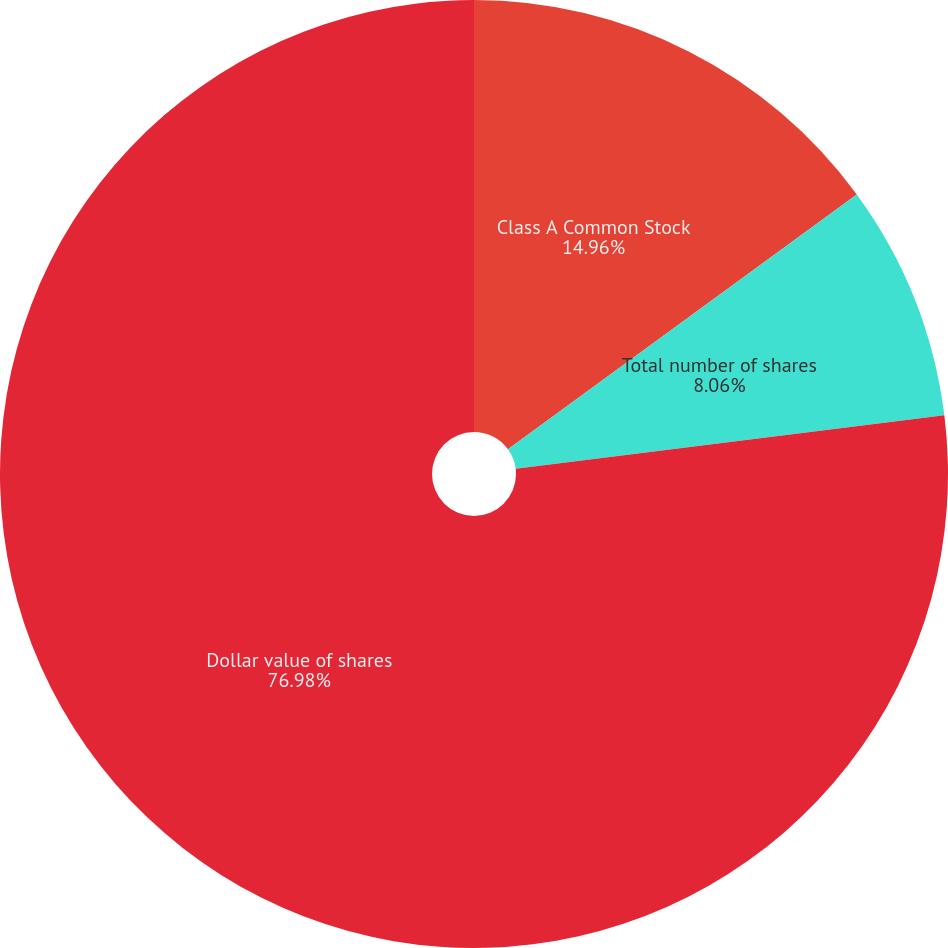Convert chart to OTSL. <chart><loc_0><loc_0><loc_500><loc_500><pie_chart><fcel>Class A Common Stock<fcel>Total number of shares<fcel>Dollar value of shares<nl><fcel>14.96%<fcel>8.06%<fcel>76.98%<nl></chart> 